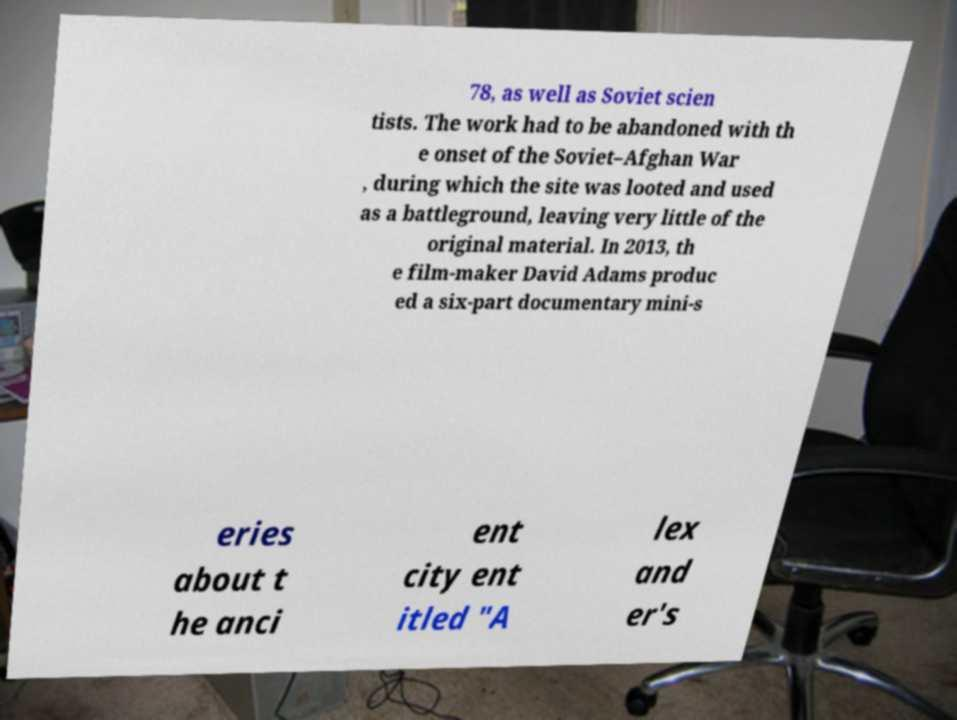Please read and relay the text visible in this image. What does it say? 78, as well as Soviet scien tists. The work had to be abandoned with th e onset of the Soviet–Afghan War , during which the site was looted and used as a battleground, leaving very little of the original material. In 2013, th e film-maker David Adams produc ed a six-part documentary mini-s eries about t he anci ent city ent itled "A lex and er's 